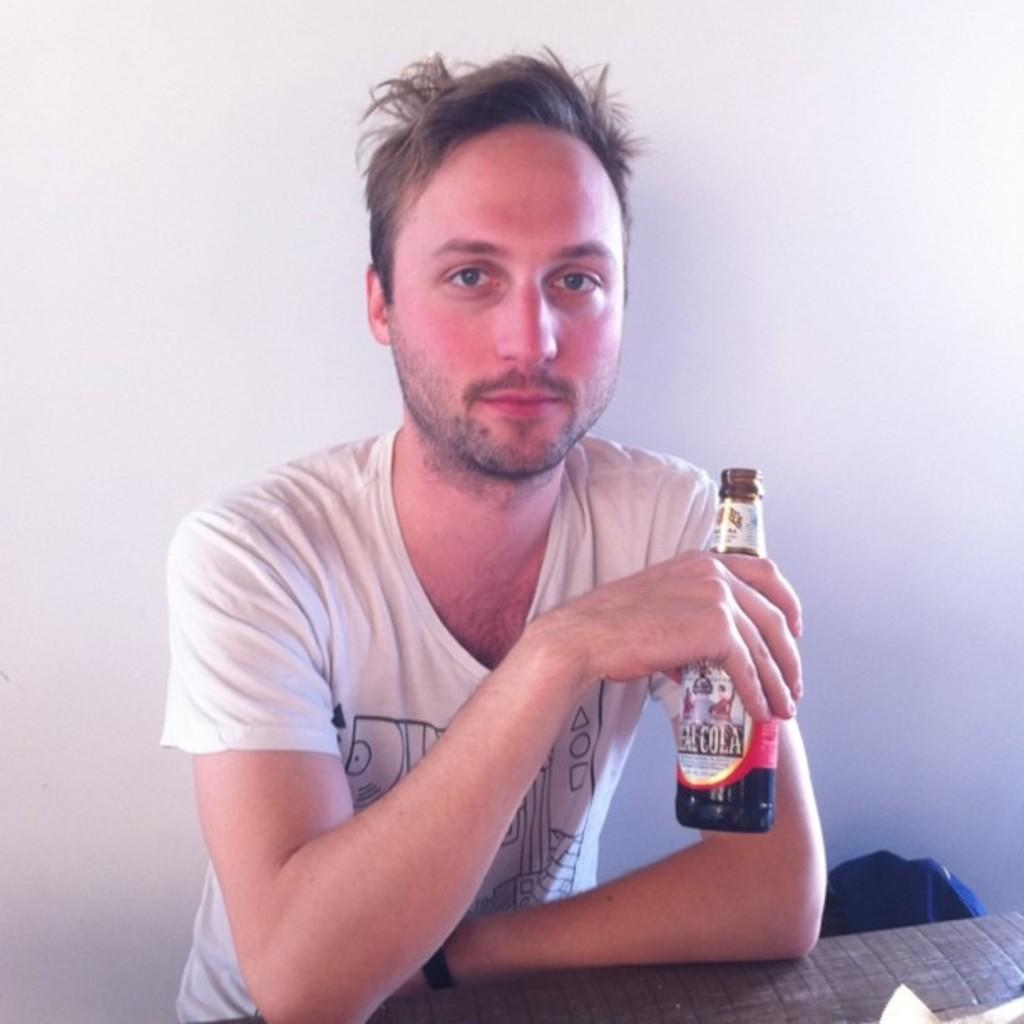What is the man in the image doing? The man is sitting on a chair in the image. What is the man wearing? The man is wearing a white t-shirt. What object is the man holding in his hand? The man is holding a wine bottle in his hand. What can be seen in the background of the image? There is a wall visible in the background of the image. What type of meat is being prepared on the grill in the image? There is no grill or meat present in the image; it features a man sitting on a chair holding a wine bottle. 